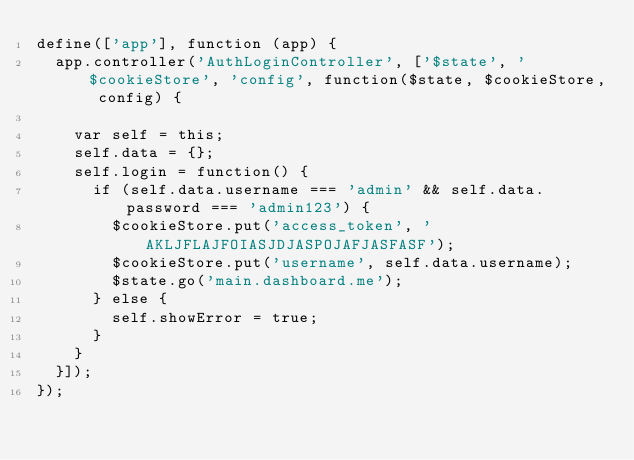<code> <loc_0><loc_0><loc_500><loc_500><_JavaScript_>define(['app'], function (app) {
  app.controller('AuthLoginController', ['$state', '$cookieStore', 'config', function($state, $cookieStore, config) {

    var self = this;
    self.data = {};
    self.login = function() {
      if (self.data.username === 'admin' && self.data.password === 'admin123') {
        $cookieStore.put('access_token', 'AKLJFLAJFOIASJDJASPOJAFJASFASF');
        $cookieStore.put('username', self.data.username);
        $state.go('main.dashboard.me');
      } else {
        self.showError = true;
      }
    }
  }]);
});
</code> 